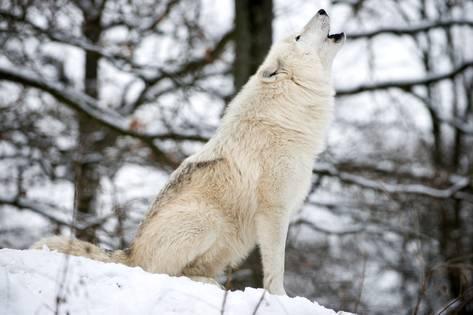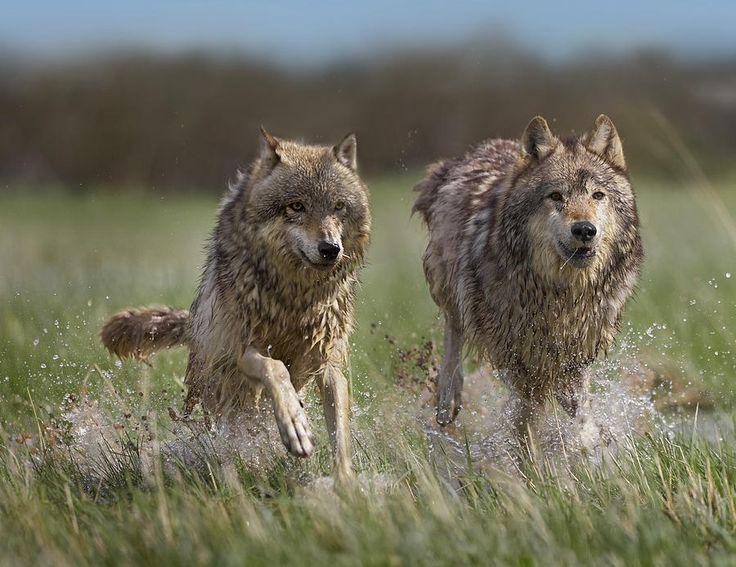The first image is the image on the left, the second image is the image on the right. Analyze the images presented: Is the assertion "The animal in the image on the left is on snow." valid? Answer yes or no. Yes. The first image is the image on the left, the second image is the image on the right. For the images displayed, is the sentence "An image shows a tawny wolf lying on the ground with front paws forward and head up." factually correct? Answer yes or no. No. 